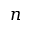<formula> <loc_0><loc_0><loc_500><loc_500>n</formula> 